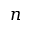<formula> <loc_0><loc_0><loc_500><loc_500>n</formula> 